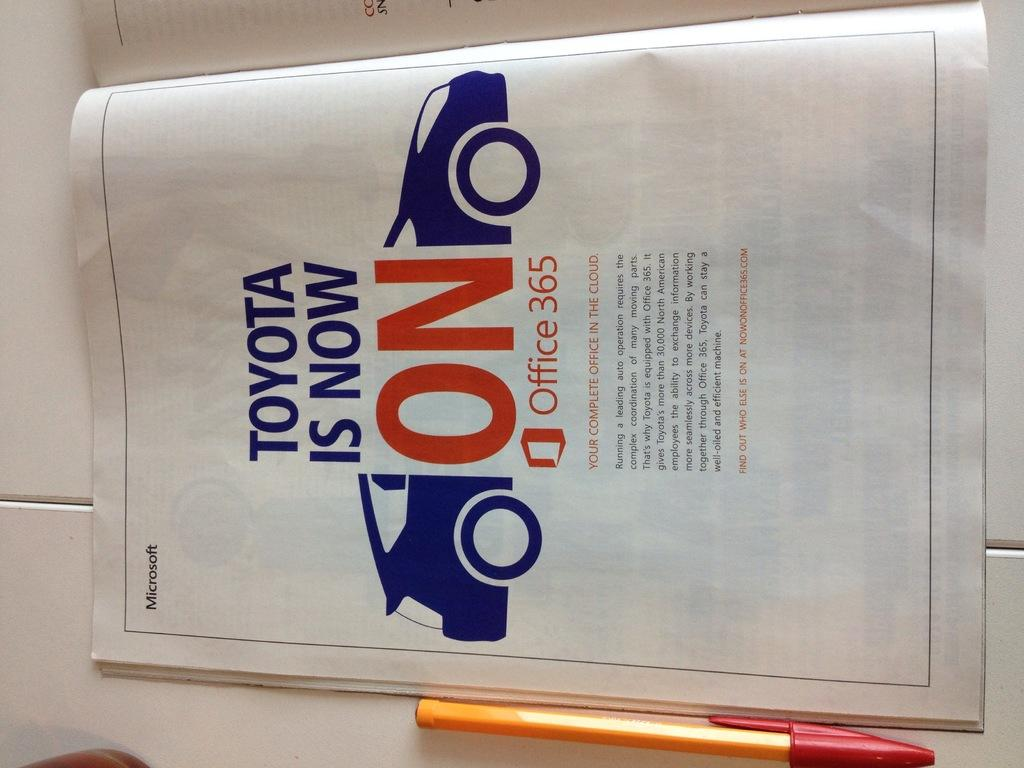What object can be seen in the image that is commonly used for writing? There is a pen in the image that is commonly used for writing. What object can be seen in the image that is commonly used for reading or learning? There is a book in the image that is commonly used for reading or learning. On what surface are the book and pen placed in the image? The book and pen are placed on a white surface in the image. How many snails can be seen crawling on the book in the image? There are no snails present in the image; it only features a book and a pen on a white surface. 